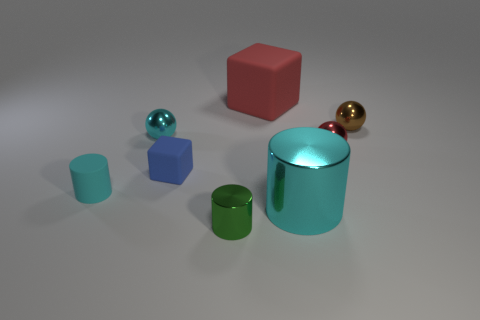There is a red object behind the small brown ball; how many matte cylinders are to the right of it? While there are several objects in the image, including cylinders, there are no matte cylinders directly to the right of the small brown ball. To the right of the brown ball, there are two shiny cylinders, one green and the larger one blue. 